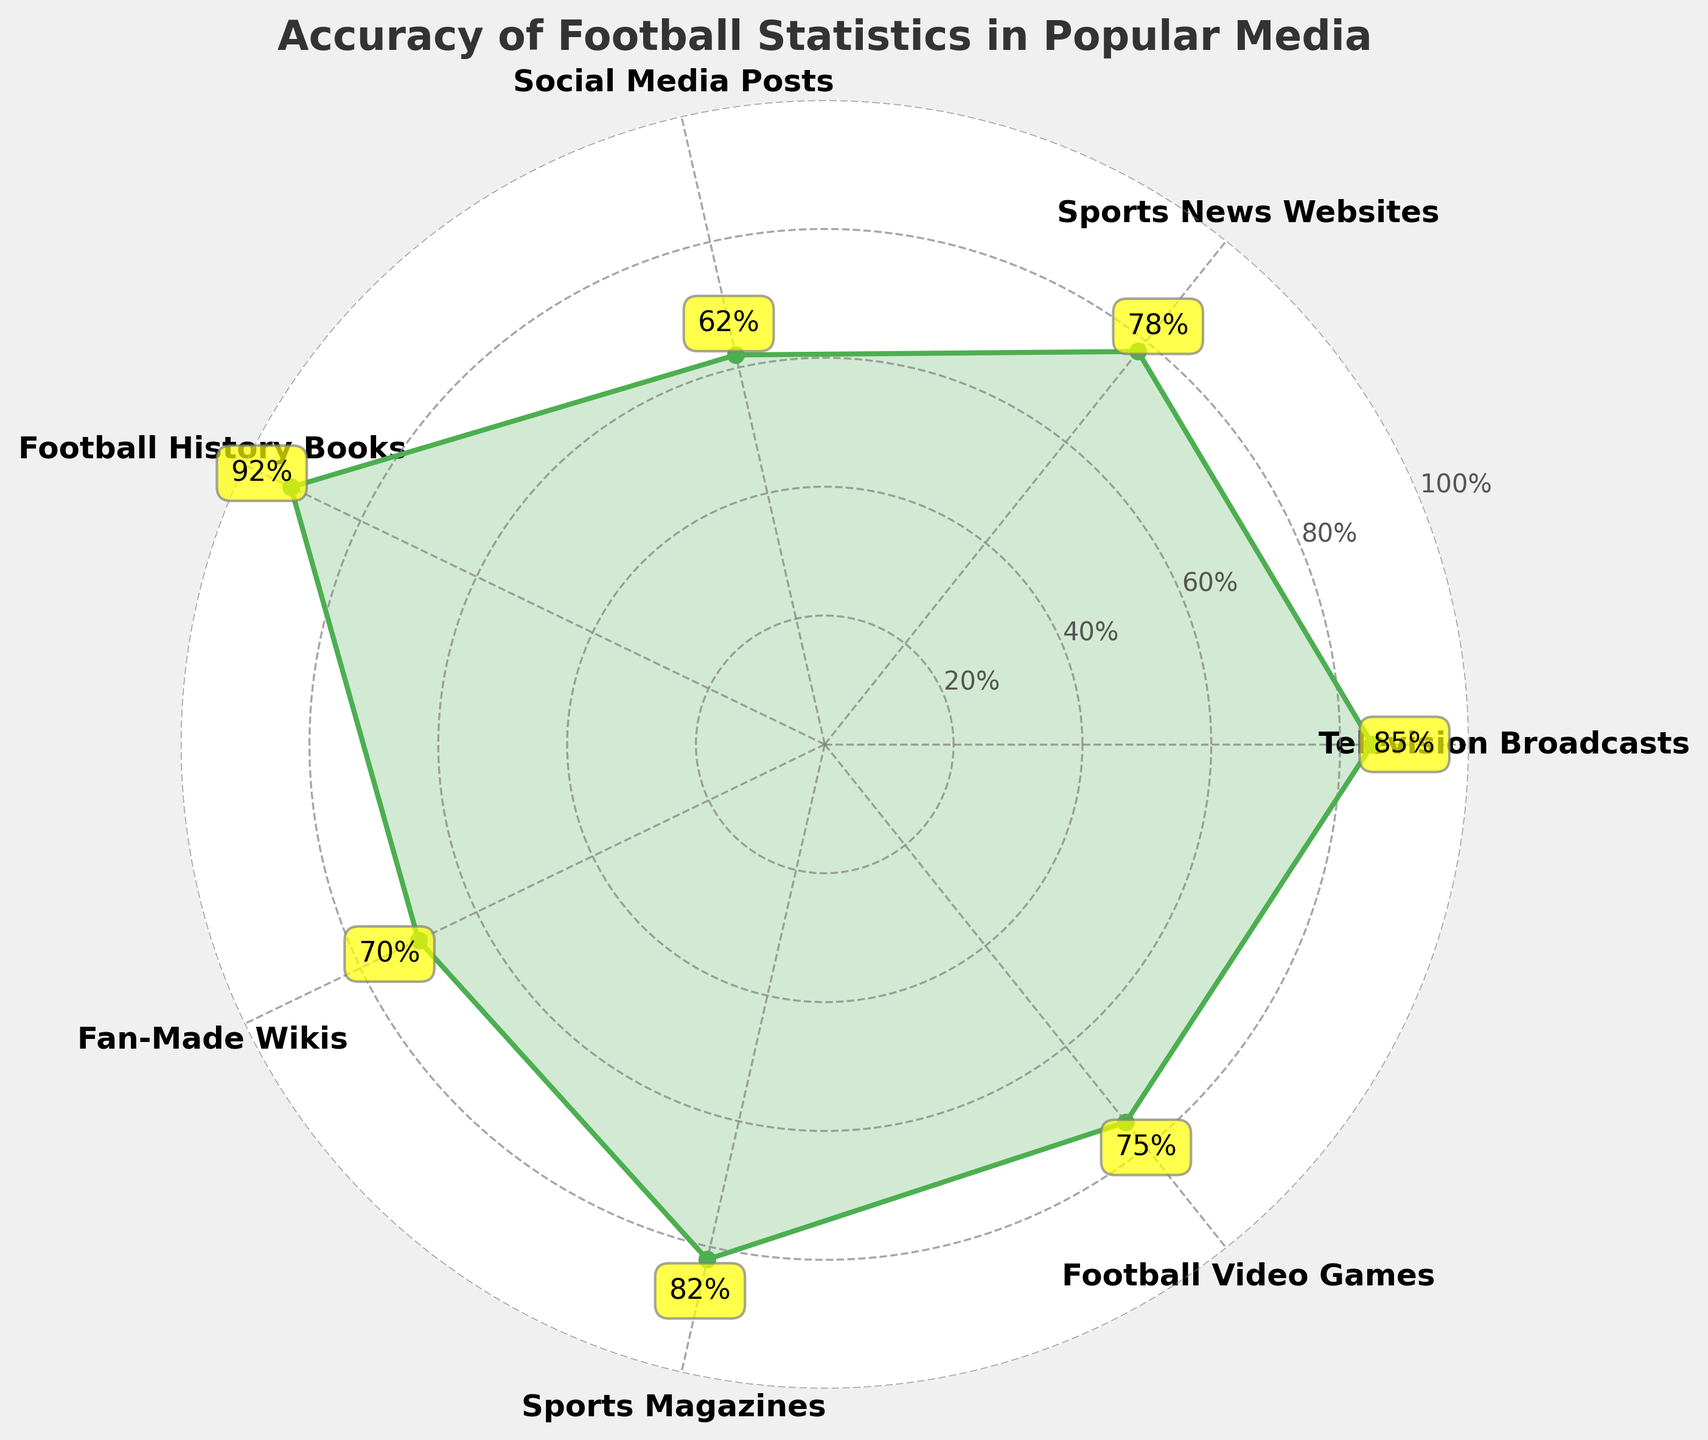what is the title of the figure? The title is usually placed at the top of the figure and is clearly labeled.
Answer: Accuracy of Football Statistics in Popular Media How many different categories are displayed in the figure? Count the number of different labels around the figure.
Answer: 7 Which category has the highest percentage of accuracy? Look for the category with the highest percentage value placed around the figure.
Answer: Football History Books What is the difference in accuracy between Social Media Posts and Sports Magazines? Subtract the percentage for Social Media Posts (62%) from the percentage for Sports Magazines (82%). 82% - 62% = 20%
Answer: 20% Which category has an accuracy percentage closest to 80%? Identify the percentage values and find the one that is nearest to 80%.
Answer: Sports Magazines What is the average accuracy percentage of all categories? Add up all the percentages and divide by the number of categories (85 + 78 + 62 + 92 + 70 + 82 + 75 = 544, then 544 / 7).
Answer: 77.71% Is the accuracy of Fan-Made Wikis greater than the accuracy of Social Media Posts? Compare the percentage accuracy of Fan-Made Wikis (70%) and Social Media Posts (62%).
Answer: Yes Between Sports News Websites and Football Video Games, which has a higher accuracy? Compare the percentage values of Sports News Websites (78%) and Football Video Games (75%).
Answer: Sports News Websites Which category has the lowest accuracy percentage? Look for the category with the smallest percentage value placed around the figure.
Answer: Social Media Posts What is the combined accuracy percentage of Television Broadcasts and Sports Magazines? Add the percentages for Television Broadcasts (85%) and Sports Magazines (82%). 85% + 82% = 167%
Answer: 167% 